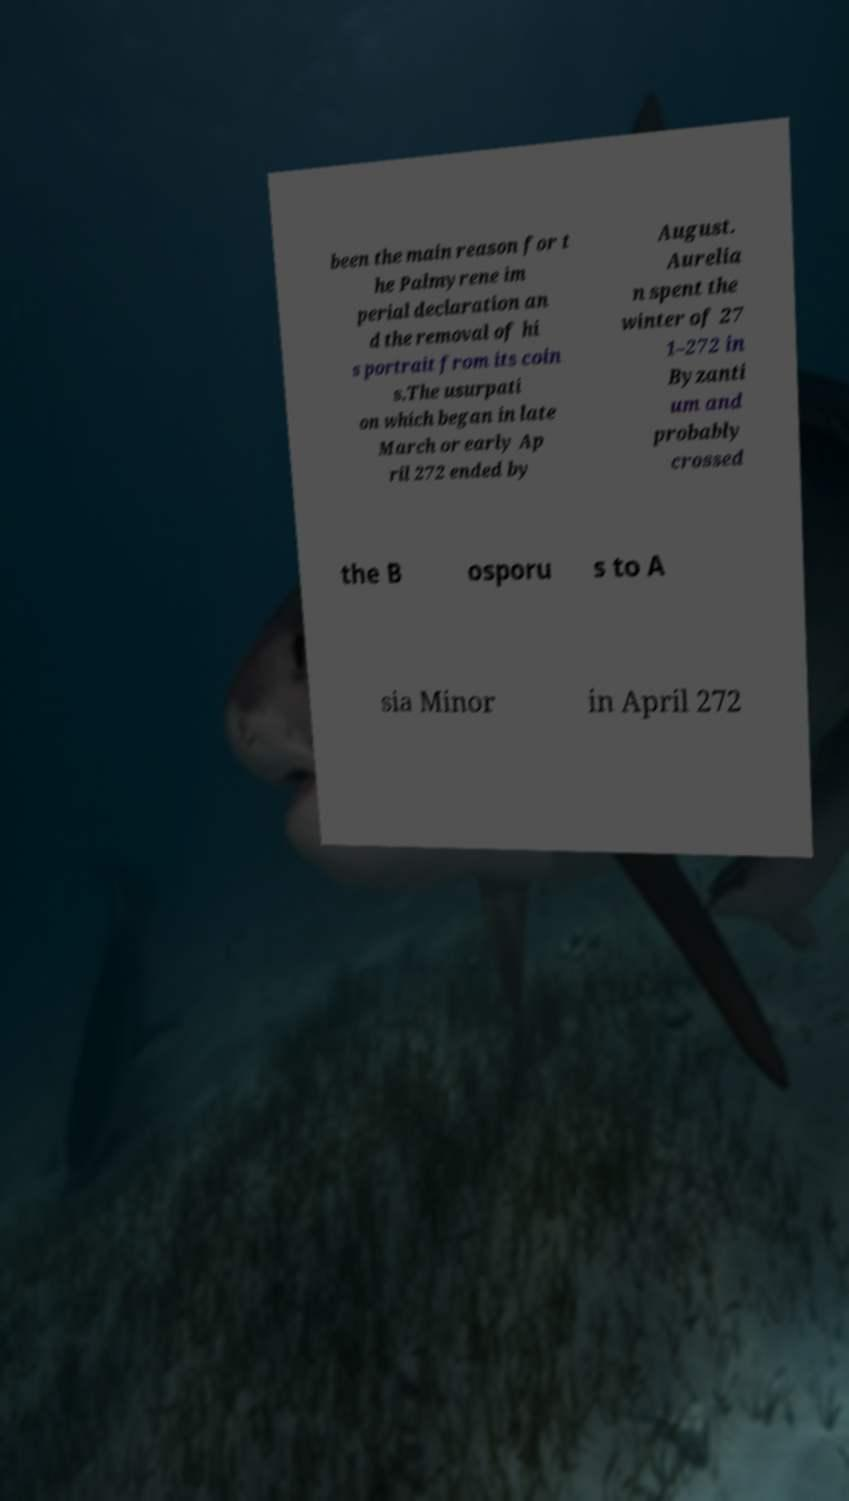Could you extract and type out the text from this image? been the main reason for t he Palmyrene im perial declaration an d the removal of hi s portrait from its coin s.The usurpati on which began in late March or early Ap ril 272 ended by August. Aurelia n spent the winter of 27 1–272 in Byzanti um and probably crossed the B osporu s to A sia Minor in April 272 